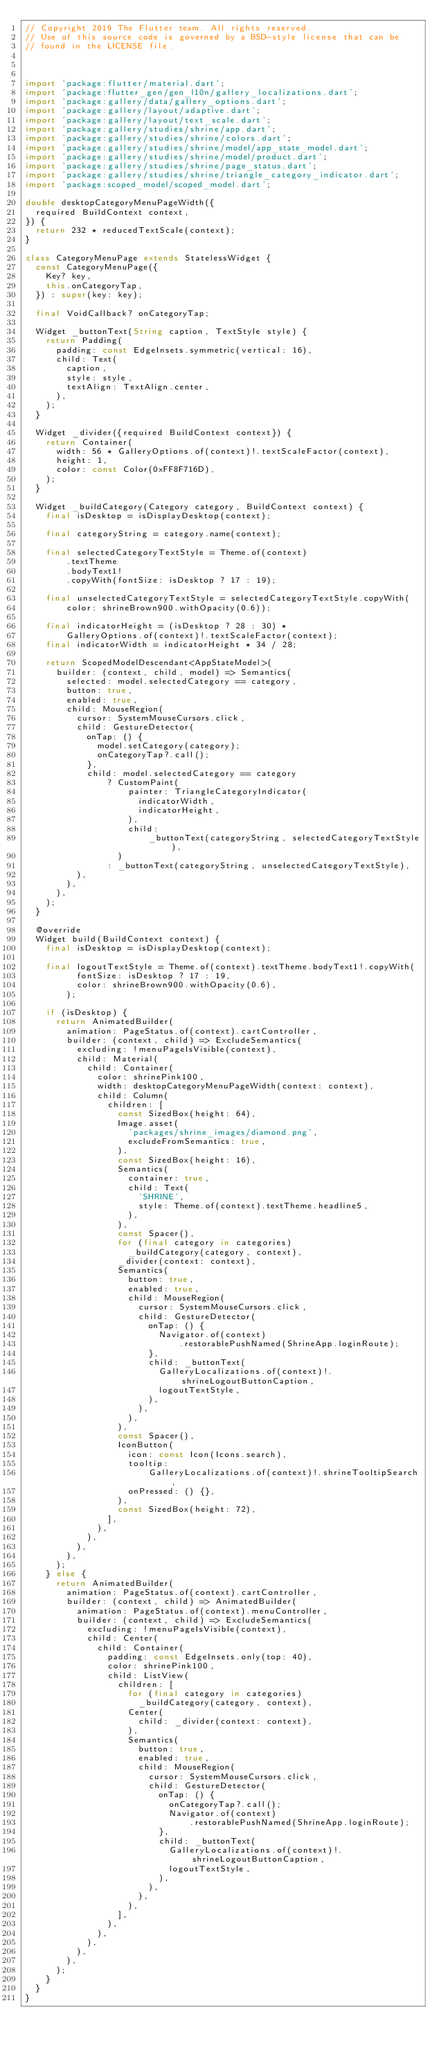<code> <loc_0><loc_0><loc_500><loc_500><_Dart_>// Copyright 2019 The Flutter team. All rights reserved.
// Use of this source code is governed by a BSD-style license that can be
// found in the LICENSE file.



import 'package:flutter/material.dart';
import 'package:flutter_gen/gen_l10n/gallery_localizations.dart';
import 'package:gallery/data/gallery_options.dart';
import 'package:gallery/layout/adaptive.dart';
import 'package:gallery/layout/text_scale.dart';
import 'package:gallery/studies/shrine/app.dart';
import 'package:gallery/studies/shrine/colors.dart';
import 'package:gallery/studies/shrine/model/app_state_model.dart';
import 'package:gallery/studies/shrine/model/product.dart';
import 'package:gallery/studies/shrine/page_status.dart';
import 'package:gallery/studies/shrine/triangle_category_indicator.dart';
import 'package:scoped_model/scoped_model.dart';

double desktopCategoryMenuPageWidth({
  required BuildContext context,
}) {
  return 232 * reducedTextScale(context);
}

class CategoryMenuPage extends StatelessWidget {
  const CategoryMenuPage({
    Key? key,
    this.onCategoryTap,
  }) : super(key: key);

  final VoidCallback? onCategoryTap;

  Widget _buttonText(String caption, TextStyle style) {
    return Padding(
      padding: const EdgeInsets.symmetric(vertical: 16),
      child: Text(
        caption,
        style: style,
        textAlign: TextAlign.center,
      ),
    );
  }

  Widget _divider({required BuildContext context}) {
    return Container(
      width: 56 * GalleryOptions.of(context)!.textScaleFactor(context),
      height: 1,
      color: const Color(0xFF8F716D),
    );
  }

  Widget _buildCategory(Category category, BuildContext context) {
    final isDesktop = isDisplayDesktop(context);

    final categoryString = category.name(context);

    final selectedCategoryTextStyle = Theme.of(context)
        .textTheme
        .bodyText1!
        .copyWith(fontSize: isDesktop ? 17 : 19);

    final unselectedCategoryTextStyle = selectedCategoryTextStyle.copyWith(
        color: shrineBrown900.withOpacity(0.6));

    final indicatorHeight = (isDesktop ? 28 : 30) *
        GalleryOptions.of(context)!.textScaleFactor(context);
    final indicatorWidth = indicatorHeight * 34 / 28;

    return ScopedModelDescendant<AppStateModel>(
      builder: (context, child, model) => Semantics(
        selected: model.selectedCategory == category,
        button: true,
        enabled: true,
        child: MouseRegion(
          cursor: SystemMouseCursors.click,
          child: GestureDetector(
            onTap: () {
              model.setCategory(category);
              onCategoryTap?.call();
            },
            child: model.selectedCategory == category
                ? CustomPaint(
                    painter: TriangleCategoryIndicator(
                      indicatorWidth,
                      indicatorHeight,
                    ),
                    child:
                        _buttonText(categoryString, selectedCategoryTextStyle),
                  )
                : _buttonText(categoryString, unselectedCategoryTextStyle),
          ),
        ),
      ),
    );
  }

  @override
  Widget build(BuildContext context) {
    final isDesktop = isDisplayDesktop(context);

    final logoutTextStyle = Theme.of(context).textTheme.bodyText1!.copyWith(
          fontSize: isDesktop ? 17 : 19,
          color: shrineBrown900.withOpacity(0.6),
        );

    if (isDesktop) {
      return AnimatedBuilder(
        animation: PageStatus.of(context).cartController,
        builder: (context, child) => ExcludeSemantics(
          excluding: !menuPageIsVisible(context),
          child: Material(
            child: Container(
              color: shrinePink100,
              width: desktopCategoryMenuPageWidth(context: context),
              child: Column(
                children: [
                  const SizedBox(height: 64),
                  Image.asset(
                    'packages/shrine_images/diamond.png',
                    excludeFromSemantics: true,
                  ),
                  const SizedBox(height: 16),
                  Semantics(
                    container: true,
                    child: Text(
                      'SHRINE',
                      style: Theme.of(context).textTheme.headline5,
                    ),
                  ),
                  const Spacer(),
                  for (final category in categories)
                    _buildCategory(category, context),
                  _divider(context: context),
                  Semantics(
                    button: true,
                    enabled: true,
                    child: MouseRegion(
                      cursor: SystemMouseCursors.click,
                      child: GestureDetector(
                        onTap: () {
                          Navigator.of(context)
                              .restorablePushNamed(ShrineApp.loginRoute);
                        },
                        child: _buttonText(
                          GalleryLocalizations.of(context)!.shrineLogoutButtonCaption,
                          logoutTextStyle,
                        ),
                      ),
                    ),
                  ),
                  const Spacer(),
                  IconButton(
                    icon: const Icon(Icons.search),
                    tooltip:
                        GalleryLocalizations.of(context)!.shrineTooltipSearch,
                    onPressed: () {},
                  ),
                  const SizedBox(height: 72),
                ],
              ),
            ),
          ),
        ),
      );
    } else {
      return AnimatedBuilder(
        animation: PageStatus.of(context).cartController,
        builder: (context, child) => AnimatedBuilder(
          animation: PageStatus.of(context).menuController,
          builder: (context, child) => ExcludeSemantics(
            excluding: !menuPageIsVisible(context),
            child: Center(
              child: Container(
                padding: const EdgeInsets.only(top: 40),
                color: shrinePink100,
                child: ListView(
                  children: [
                    for (final category in categories)
                      _buildCategory(category, context),
                    Center(
                      child: _divider(context: context),
                    ),
                    Semantics(
                      button: true,
                      enabled: true,
                      child: MouseRegion(
                        cursor: SystemMouseCursors.click,
                        child: GestureDetector(
                          onTap: () {
                            onCategoryTap?.call();
                            Navigator.of(context)
                                .restorablePushNamed(ShrineApp.loginRoute);
                          },
                          child: _buttonText(
                            GalleryLocalizations.of(context)!.shrineLogoutButtonCaption,
                            logoutTextStyle,
                          ),
                        ),
                      ),
                    ),
                  ],
                ),
              ),
            ),
          ),
        ),
      );
    }
  }
}
</code> 